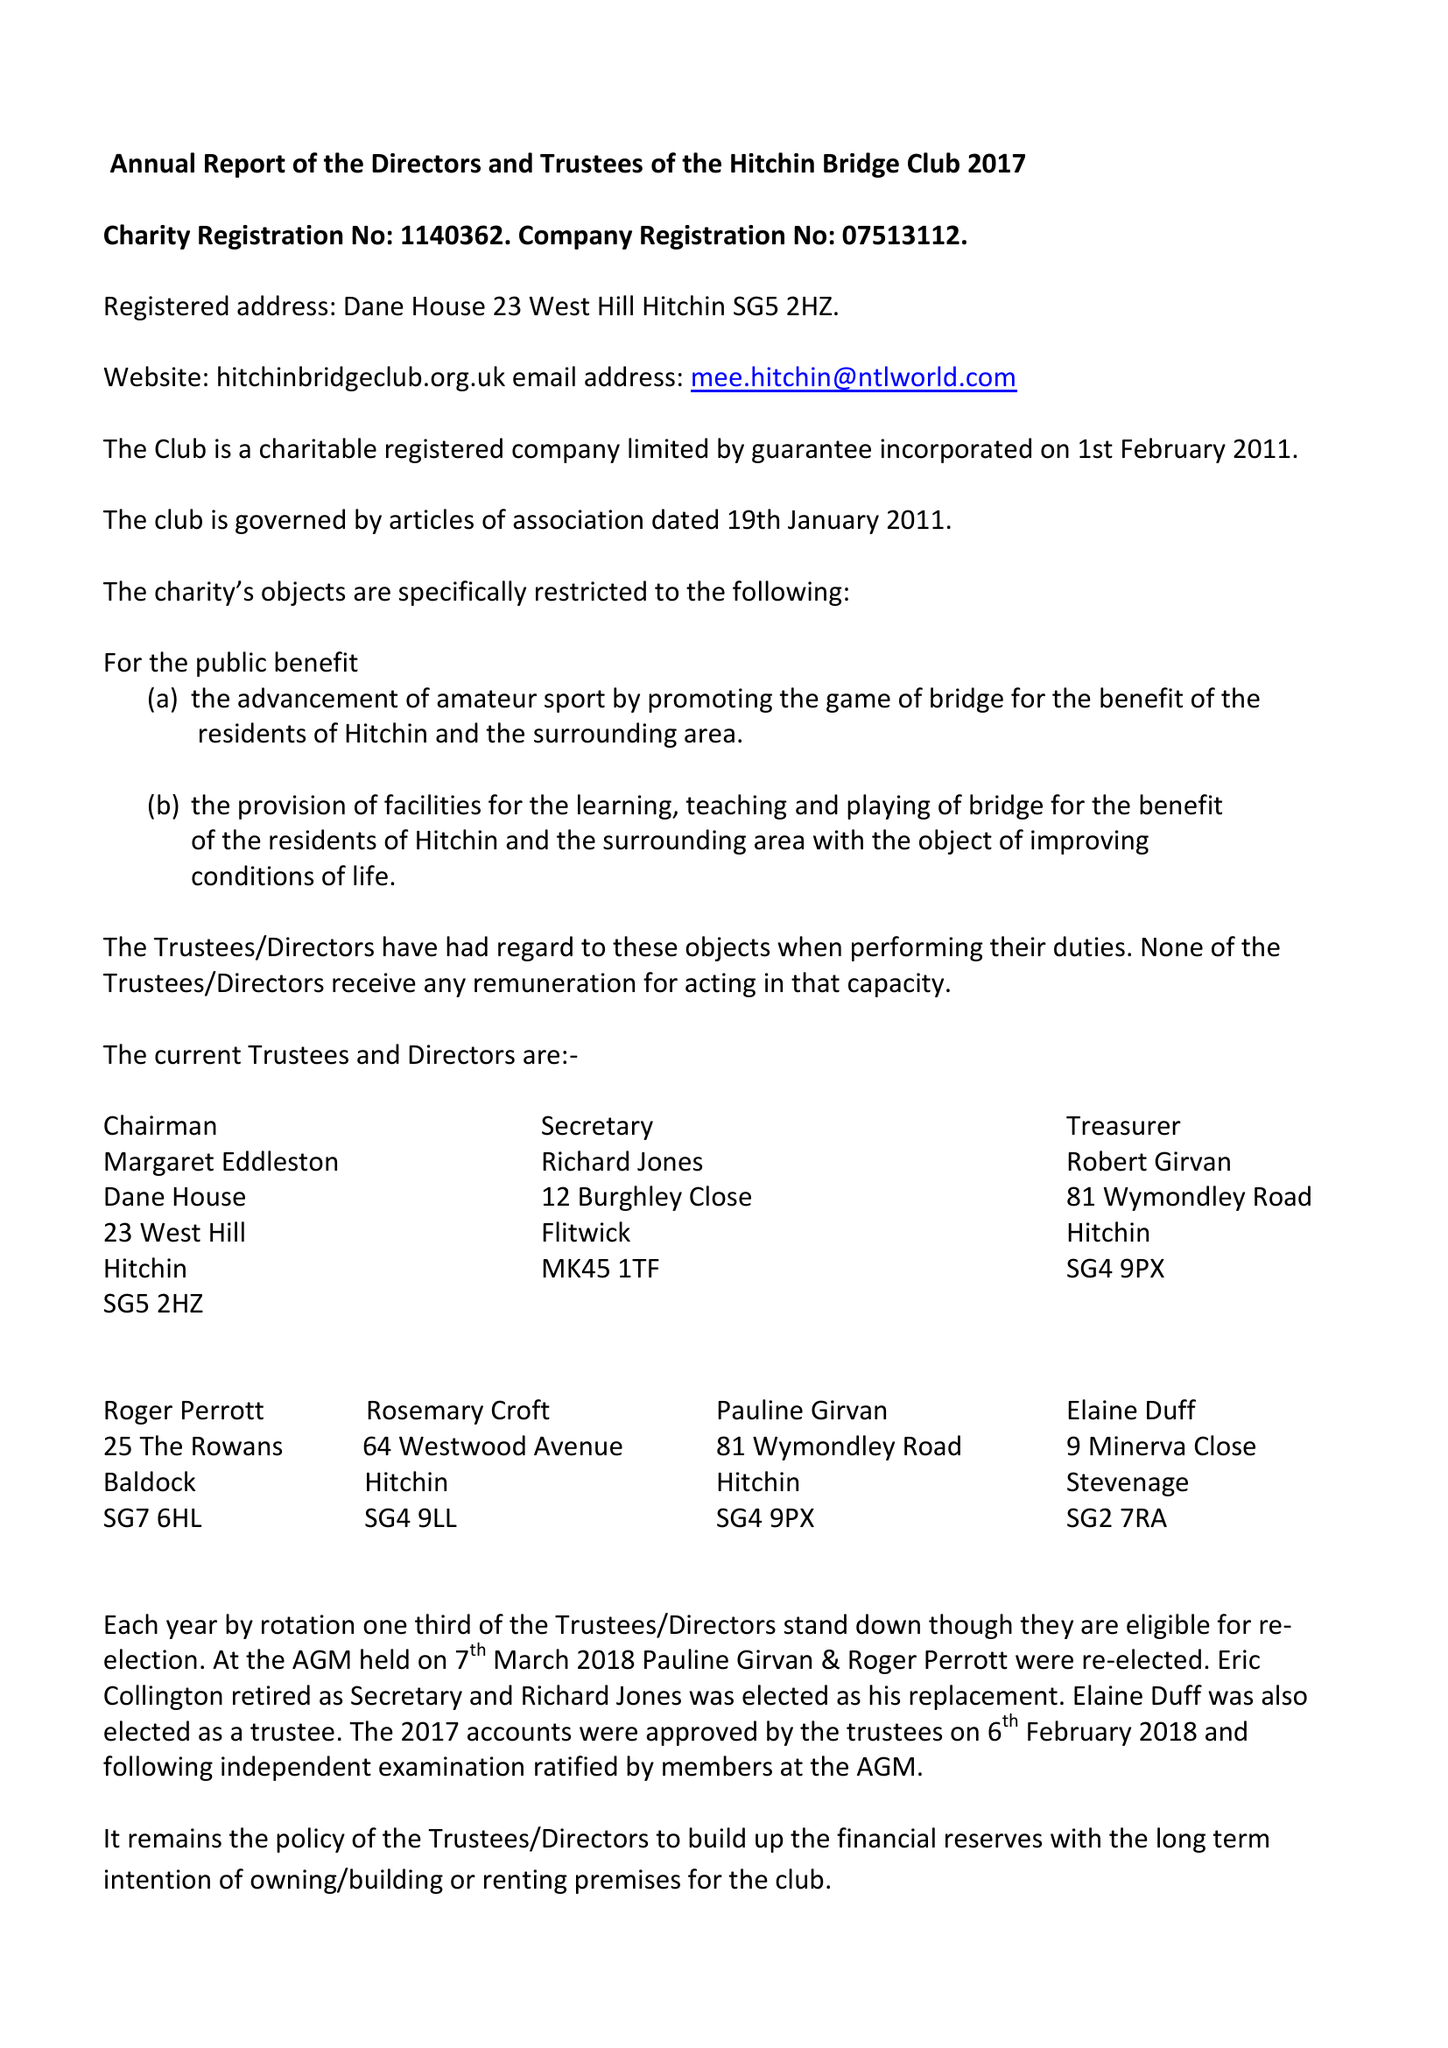What is the value for the spending_annually_in_british_pounds?
Answer the question using a single word or phrase. 18497.00 